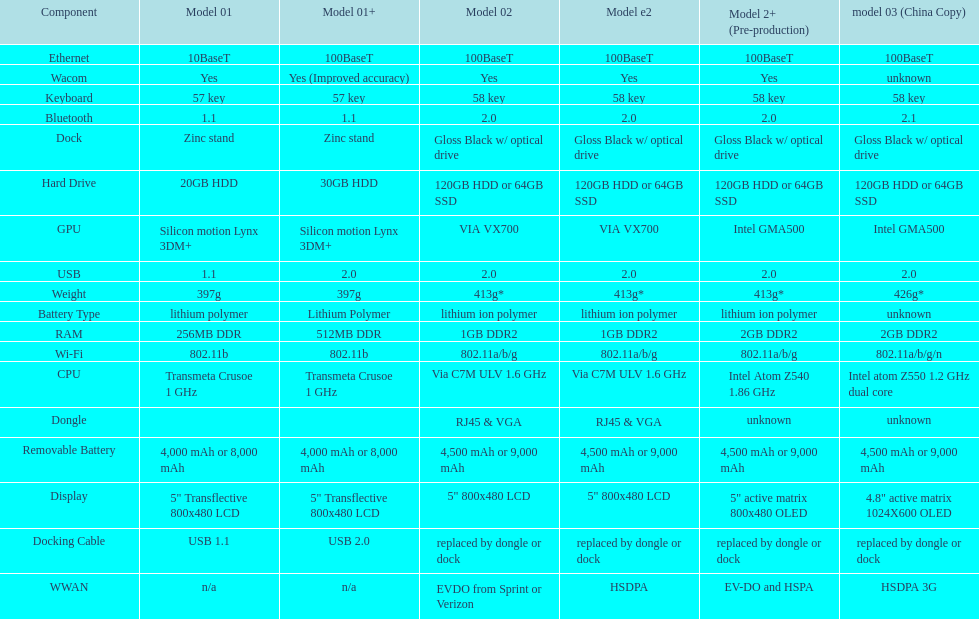What component comes after bluetooth? Wacom. Could you parse the entire table? {'header': ['Component', 'Model 01', 'Model 01+', 'Model 02', 'Model e2', 'Model 2+ (Pre-production)', 'model 03 (China Copy)'], 'rows': [['Ethernet', '10BaseT', '100BaseT', '100BaseT', '100BaseT', '100BaseT', '100BaseT'], ['Wacom', 'Yes', 'Yes (Improved accuracy)', 'Yes', 'Yes', 'Yes', 'unknown'], ['Keyboard', '57 key', '57 key', '58 key', '58 key', '58 key', '58 key'], ['Bluetooth', '1.1', '1.1', '2.0', '2.0', '2.0', '2.1'], ['Dock', 'Zinc stand', 'Zinc stand', 'Gloss Black w/ optical drive', 'Gloss Black w/ optical drive', 'Gloss Black w/ optical drive', 'Gloss Black w/ optical drive'], ['Hard Drive', '20GB HDD', '30GB HDD', '120GB HDD or 64GB SSD', '120GB HDD or 64GB SSD', '120GB HDD or 64GB SSD', '120GB HDD or 64GB SSD'], ['GPU', 'Silicon motion Lynx 3DM+', 'Silicon motion Lynx 3DM+', 'VIA VX700', 'VIA VX700', 'Intel GMA500', 'Intel GMA500'], ['USB', '1.1', '2.0', '2.0', '2.0', '2.0', '2.0'], ['Weight', '397g', '397g', '413g*', '413g*', '413g*', '426g*'], ['Battery Type', 'lithium polymer', 'Lithium Polymer', 'lithium ion polymer', 'lithium ion polymer', 'lithium ion polymer', 'unknown'], ['RAM', '256MB DDR', '512MB DDR', '1GB DDR2', '1GB DDR2', '2GB DDR2', '2GB DDR2'], ['Wi-Fi', '802.11b', '802.11b', '802.11a/b/g', '802.11a/b/g', '802.11a/b/g', '802.11a/b/g/n'], ['CPU', 'Transmeta Crusoe 1\xa0GHz', 'Transmeta Crusoe 1\xa0GHz', 'Via C7M ULV 1.6\xa0GHz', 'Via C7M ULV 1.6\xa0GHz', 'Intel Atom Z540 1.86\xa0GHz', 'Intel atom Z550 1.2\xa0GHz dual core'], ['Dongle', '', '', 'RJ45 & VGA', 'RJ45 & VGA', 'unknown', 'unknown'], ['Removable Battery', '4,000 mAh or 8,000 mAh', '4,000 mAh or 8,000 mAh', '4,500 mAh or 9,000 mAh', '4,500 mAh or 9,000 mAh', '4,500 mAh or 9,000 mAh', '4,500 mAh or 9,000 mAh'], ['Display', '5" Transflective 800x480 LCD', '5" Transflective 800x480 LCD', '5" 800x480 LCD', '5" 800x480 LCD', '5" active matrix 800x480 OLED', '4.8" active matrix 1024X600 OLED'], ['Docking Cable', 'USB 1.1', 'USB 2.0', 'replaced by dongle or dock', 'replaced by dongle or dock', 'replaced by dongle or dock', 'replaced by dongle or dock'], ['WWAN', 'n/a', 'n/a', 'EVDO from Sprint or Verizon', 'HSDPA', 'EV-DO and HSPA', 'HSDPA 3G']]} 